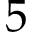<formula> <loc_0><loc_0><loc_500><loc_500>5</formula> 